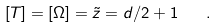Convert formula to latex. <formula><loc_0><loc_0><loc_500><loc_500>[ T ] = [ \Omega ] = \tilde { z } = d / 2 + 1 \quad .</formula> 